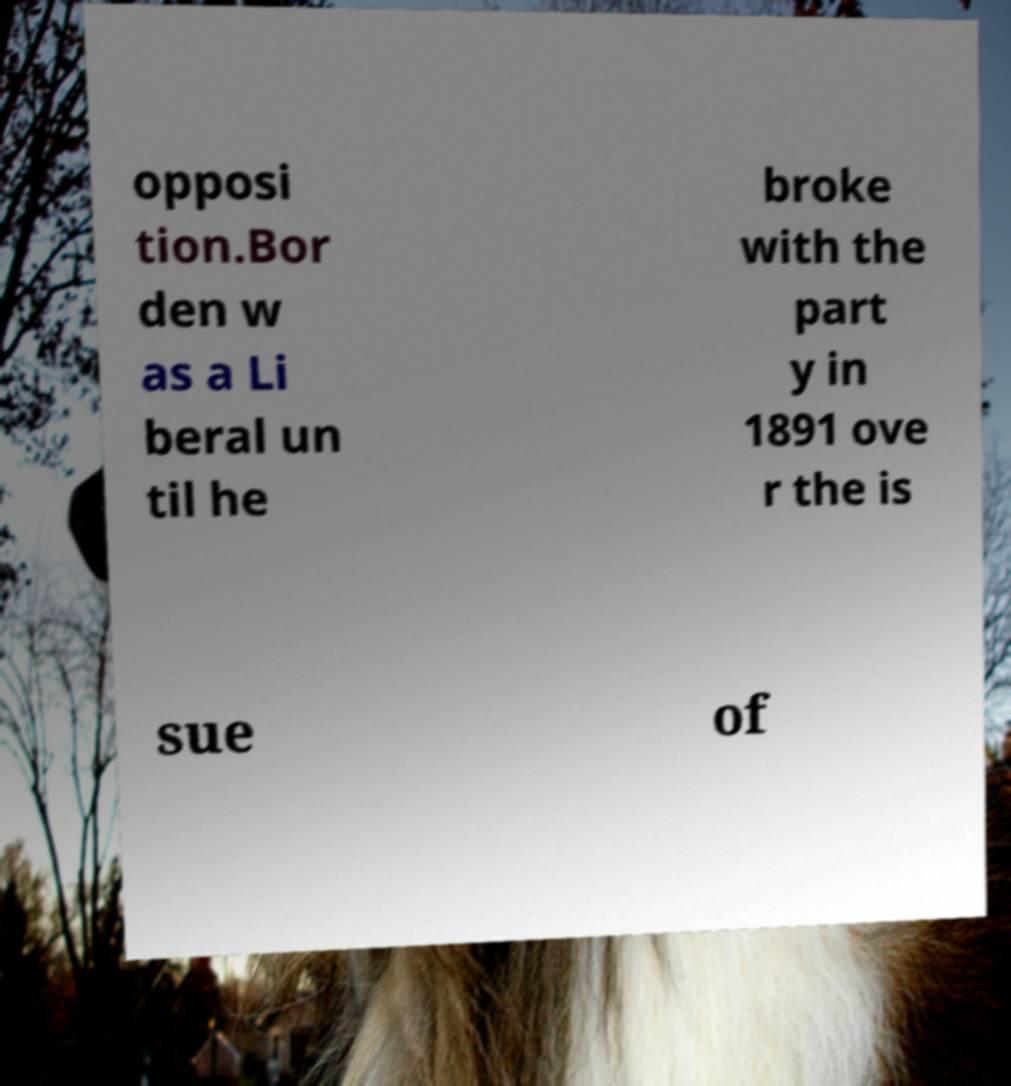Can you read and provide the text displayed in the image?This photo seems to have some interesting text. Can you extract and type it out for me? opposi tion.Bor den w as a Li beral un til he broke with the part y in 1891 ove r the is sue of 